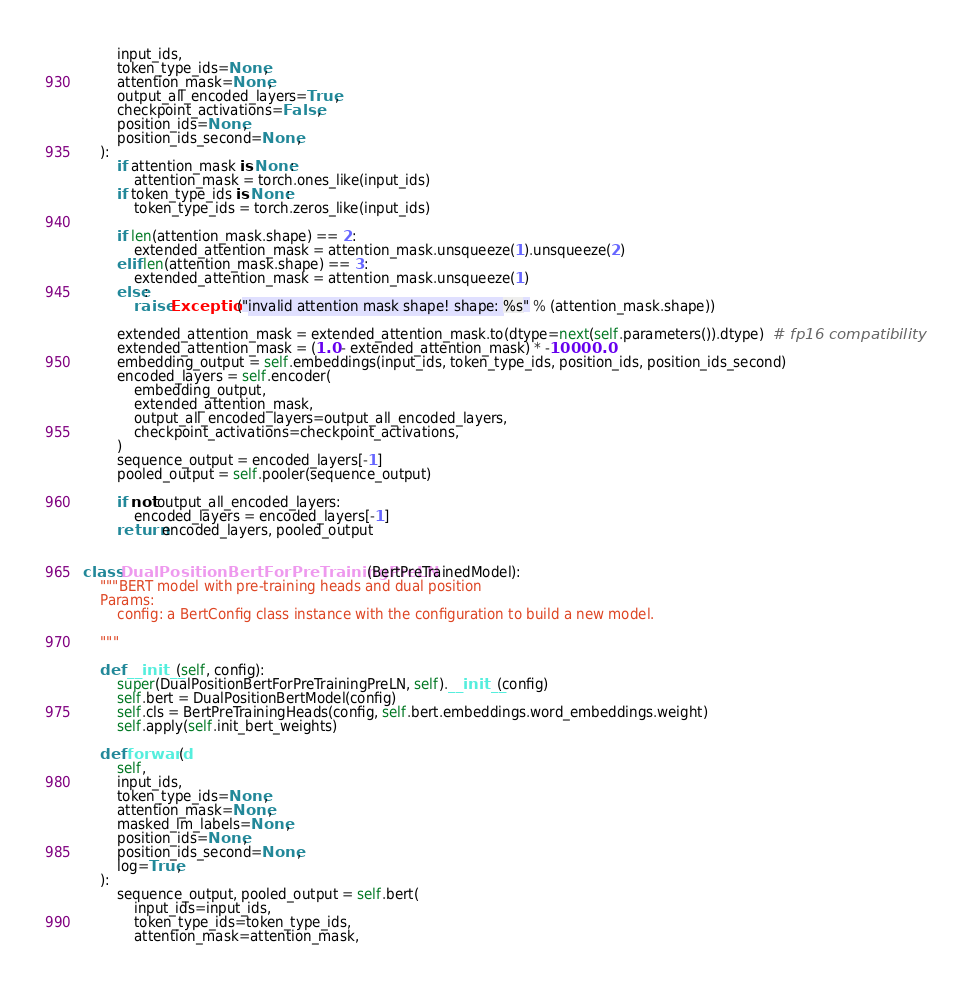Convert code to text. <code><loc_0><loc_0><loc_500><loc_500><_Python_>        input_ids,
        token_type_ids=None,
        attention_mask=None,
        output_all_encoded_layers=True,
        checkpoint_activations=False,
        position_ids=None,
        position_ids_second=None,
    ):
        if attention_mask is None:
            attention_mask = torch.ones_like(input_ids)
        if token_type_ids is None:
            token_type_ids = torch.zeros_like(input_ids)

        if len(attention_mask.shape) == 2:
            extended_attention_mask = attention_mask.unsqueeze(1).unsqueeze(2)
        elif len(attention_mask.shape) == 3:
            extended_attention_mask = attention_mask.unsqueeze(1)
        else:
            raise Exception("invalid attention mask shape! shape: %s" % (attention_mask.shape))

        extended_attention_mask = extended_attention_mask.to(dtype=next(self.parameters()).dtype)  # fp16 compatibility
        extended_attention_mask = (1.0 - extended_attention_mask) * -10000.0
        embedding_output = self.embeddings(input_ids, token_type_ids, position_ids, position_ids_second)
        encoded_layers = self.encoder(
            embedding_output,
            extended_attention_mask,
            output_all_encoded_layers=output_all_encoded_layers,
            checkpoint_activations=checkpoint_activations,
        )
        sequence_output = encoded_layers[-1]
        pooled_output = self.pooler(sequence_output)

        if not output_all_encoded_layers:
            encoded_layers = encoded_layers[-1]
        return encoded_layers, pooled_output


class DualPositionBertForPreTrainingPreLN(BertPreTrainedModel):
    """BERT model with pre-training heads and dual position
    Params:
        config: a BertConfig class instance with the configuration to build a new model.

    """

    def __init__(self, config):
        super(DualPositionBertForPreTrainingPreLN, self).__init__(config)
        self.bert = DualPositionBertModel(config)
        self.cls = BertPreTrainingHeads(config, self.bert.embeddings.word_embeddings.weight)
        self.apply(self.init_bert_weights)

    def forward(
        self,
        input_ids,
        token_type_ids=None,
        attention_mask=None,
        masked_lm_labels=None,
        position_ids=None,
        position_ids_second=None,
        log=True,
    ):
        sequence_output, pooled_output = self.bert(
            input_ids=input_ids,
            token_type_ids=token_type_ids,
            attention_mask=attention_mask,</code> 